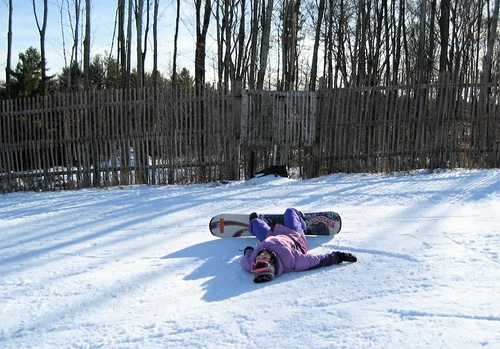Describe the objects in this image and their specific colors. I can see people in lightblue, purple, black, and navy tones and snowboard in lightblue, black, and gray tones in this image. 